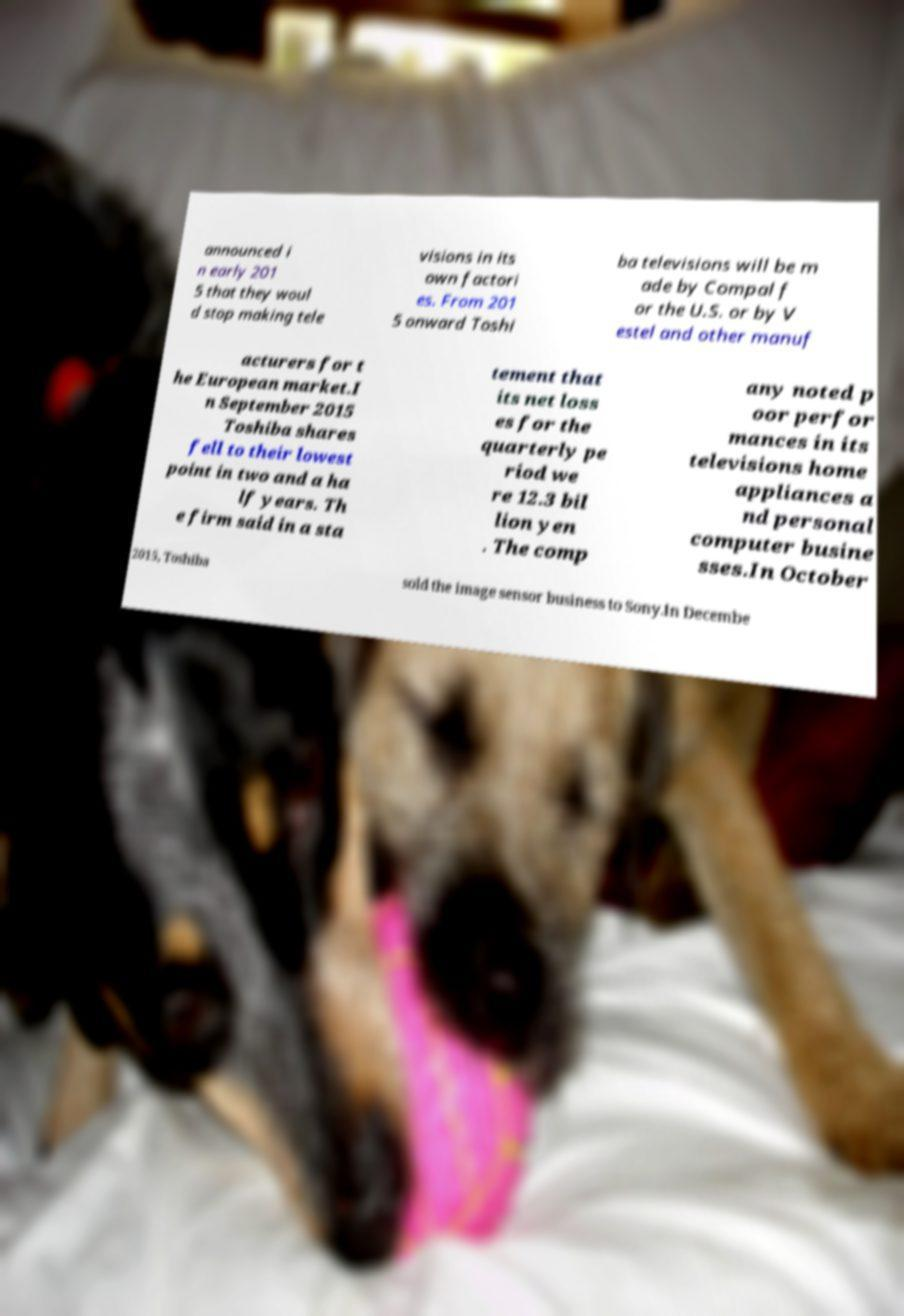Could you assist in decoding the text presented in this image and type it out clearly? announced i n early 201 5 that they woul d stop making tele visions in its own factori es. From 201 5 onward Toshi ba televisions will be m ade by Compal f or the U.S. or by V estel and other manuf acturers for t he European market.I n September 2015 Toshiba shares fell to their lowest point in two and a ha lf years. Th e firm said in a sta tement that its net loss es for the quarterly pe riod we re 12.3 bil lion yen . The comp any noted p oor perfor mances in its televisions home appliances a nd personal computer busine sses.In October 2015, Toshiba sold the image sensor business to Sony.In Decembe 